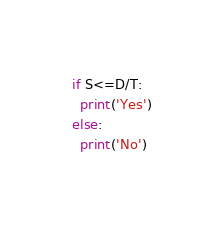<code> <loc_0><loc_0><loc_500><loc_500><_Python_>if S<=D/T:
  print('Yes')
else:
  print('No')
  </code> 